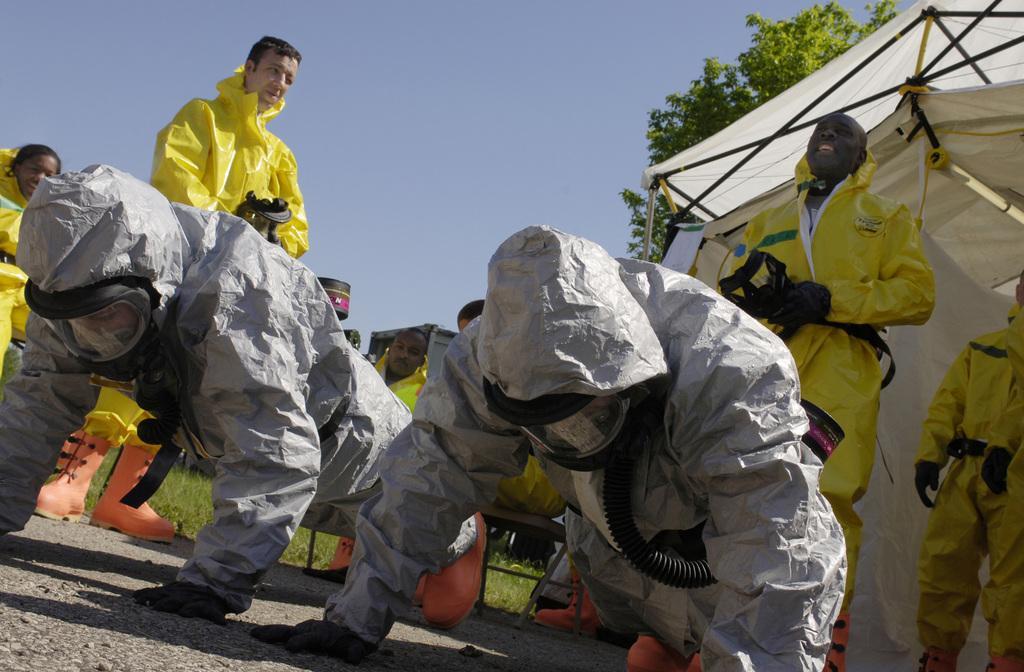In one or two sentences, can you explain what this image depicts? There are two persons in gray color dresses doing push-ups on the road. In the background, there are persons in yellow color dresses standing, there are persons in yellow color dresses sitting, there is a tent, tree and blue sky. 